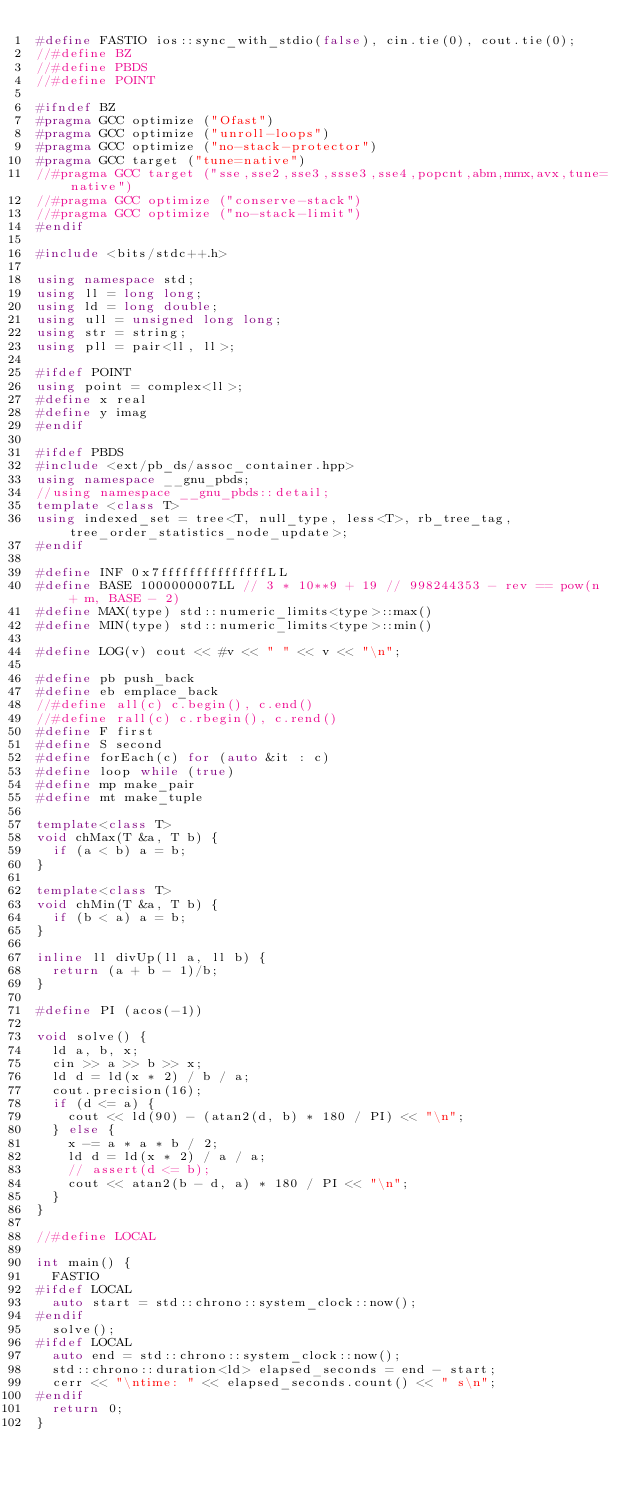Convert code to text. <code><loc_0><loc_0><loc_500><loc_500><_C++_>#define FASTIO ios::sync_with_stdio(false), cin.tie(0), cout.tie(0);
//#define BZ
//#define PBDS
//#define POINT

#ifndef BZ
#pragma GCC optimize ("Ofast")
#pragma GCC optimize ("unroll-loops")
#pragma GCC optimize ("no-stack-protector")
#pragma GCC target ("tune=native")
//#pragma GCC target ("sse,sse2,sse3,ssse3,sse4,popcnt,abm,mmx,avx,tune=native")
//#pragma GCC optimize ("conserve-stack")
//#pragma GCC optimize ("no-stack-limit")
#endif

#include <bits/stdc++.h>

using namespace std;
using ll = long long;
using ld = long double;
using ull = unsigned long long;
using str = string;
using pll = pair<ll, ll>;

#ifdef POINT
using point = complex<ll>;
#define x real
#define y imag
#endif

#ifdef PBDS
#include <ext/pb_ds/assoc_container.hpp>
using namespace __gnu_pbds;
//using namespace __gnu_pbds::detail;
template <class T>
using indexed_set = tree<T, null_type, less<T>, rb_tree_tag, tree_order_statistics_node_update>;
#endif

#define INF 0x7fffffffffffffffLL
#define BASE 1000000007LL // 3 * 10**9 + 19 // 998244353 - rev == pow(n + m, BASE - 2)
#define MAX(type) std::numeric_limits<type>::max()
#define MIN(type) std::numeric_limits<type>::min()

#define LOG(v) cout << #v << " " << v << "\n";

#define pb push_back
#define eb emplace_back
//#define all(c) c.begin(), c.end()
//#define rall(c) c.rbegin(), c.rend()
#define F first
#define S second
#define forEach(c) for (auto &it : c)
#define loop while (true)
#define mp make_pair
#define mt make_tuple

template<class T>
void chMax(T &a, T b) {
	if (a < b) a = b;
}

template<class T>
void chMin(T &a, T b) {
	if (b < a) a = b;
}

inline ll divUp(ll a, ll b) {
	return (a + b - 1)/b;
}

#define PI (acos(-1))

void solve() {
	ld a, b, x;
	cin >> a >> b >> x;
	ld d = ld(x * 2) / b / a;
	cout.precision(16);
	if (d <= a) {
		cout << ld(90) - (atan2(d, b) * 180 / PI) << "\n";
	} else {
		x -= a * a * b / 2;
		ld d = ld(x * 2) / a / a;
		// assert(d <= b);
		cout << atan2(b - d, a) * 180 / PI << "\n";
	}
}

//#define LOCAL

int main() {
	FASTIO
#ifdef LOCAL
	auto start = std::chrono::system_clock::now();
#endif
	solve();
#ifdef LOCAL
	auto end = std::chrono::system_clock::now();
	std::chrono::duration<ld> elapsed_seconds = end - start;
	cerr << "\ntime: " << elapsed_seconds.count() << " s\n";
#endif
	return 0;
}
</code> 